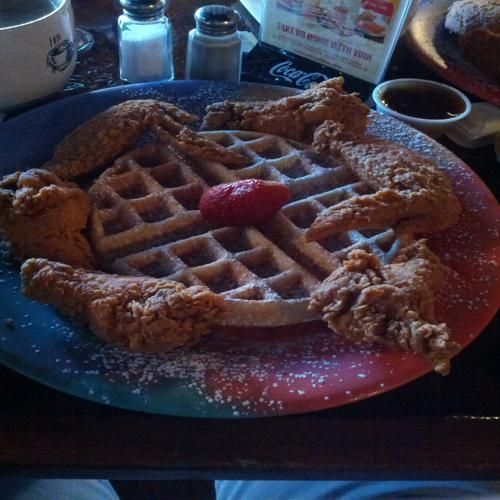Can you describe the setting or occasion where this meal might be typically enjoyed? This dish is commonly enjoyed in a casual dining setting or at brunch. It's a popular comfort food in the Southern United States, and it's often associated with a leisurely weekend meal with friends and family.  What toppings or sides could complement this dish? Traditional toppings include maple syrup and butter, while some might enjoy a sprinkle of powdered sugar or hot sauce. Sides that can complement this dish include coleslaw, macaroni and cheese, or a light salad to balance the richness. 